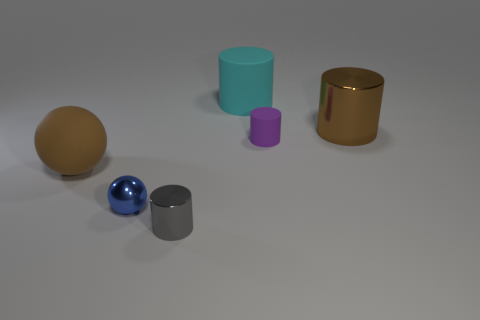Are there any big rubber things that have the same shape as the large shiny object?
Your answer should be very brief. Yes. What material is the cyan cylinder?
Ensure brevity in your answer.  Rubber. Are there any small things left of the gray shiny thing?
Your answer should be compact. Yes. There is a metallic cylinder that is in front of the tiny blue metallic object; how many purple things are in front of it?
Offer a very short reply. 0. There is a purple cylinder that is the same size as the blue ball; what is it made of?
Provide a short and direct response. Rubber. What number of big cyan matte objects are on the right side of the large rubber ball?
Provide a short and direct response. 1. How many balls are either gray metallic things or large metallic objects?
Ensure brevity in your answer.  0. What is the size of the object that is both behind the blue metallic sphere and on the left side of the small metal cylinder?
Your response must be concise. Large. What number of other things are the same color as the tiny metal ball?
Provide a succinct answer. 0. Are the small purple thing and the big object on the right side of the big rubber cylinder made of the same material?
Provide a succinct answer. No. 